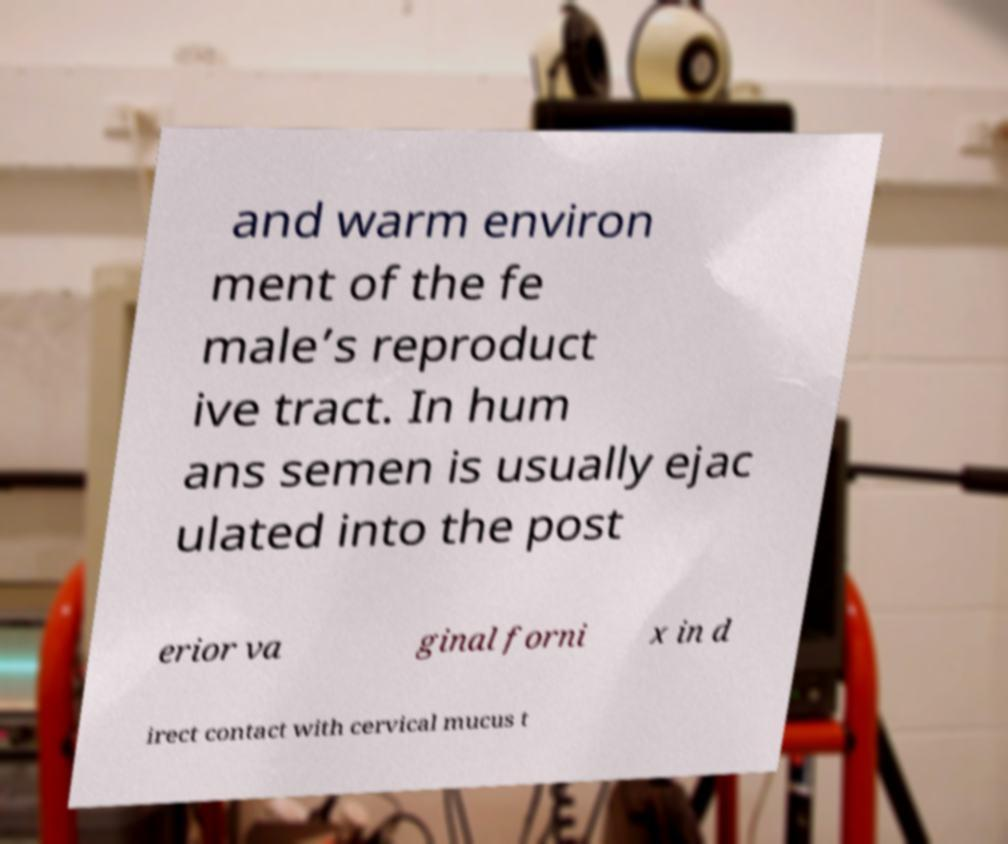Can you read and provide the text displayed in the image?This photo seems to have some interesting text. Can you extract and type it out for me? and warm environ ment of the fe male’s reproduct ive tract. In hum ans semen is usually ejac ulated into the post erior va ginal forni x in d irect contact with cervical mucus t 